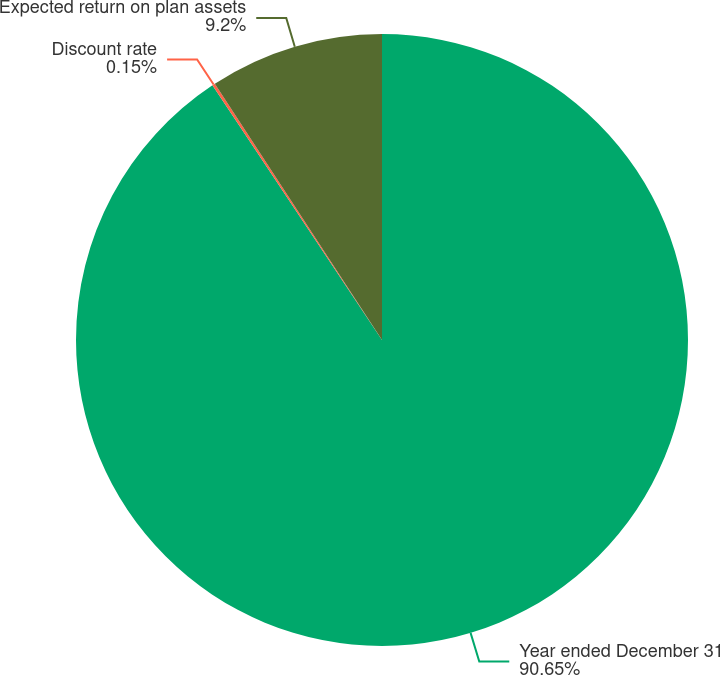<chart> <loc_0><loc_0><loc_500><loc_500><pie_chart><fcel>Year ended December 31<fcel>Discount rate<fcel>Expected return on plan assets<nl><fcel>90.66%<fcel>0.15%<fcel>9.2%<nl></chart> 